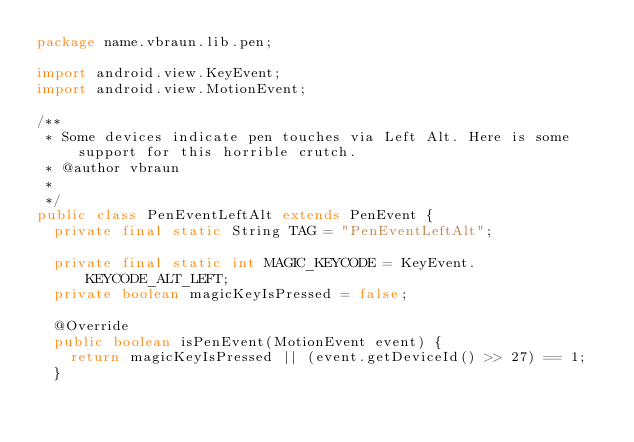<code> <loc_0><loc_0><loc_500><loc_500><_Java_>package name.vbraun.lib.pen;

import android.view.KeyEvent;
import android.view.MotionEvent;

/**
 * Some devices indicate pen touches via Left Alt. Here is some support for this horrible crutch.
 * @author vbraun
 *
 */
public class PenEventLeftAlt extends PenEvent {
	private final static String TAG = "PenEventLeftAlt";

	private final static int MAGIC_KEYCODE = KeyEvent.KEYCODE_ALT_LEFT;
	private boolean magicKeyIsPressed = false;
	
	@Override
	public boolean isPenEvent(MotionEvent event) {
		return magicKeyIsPressed || (event.getDeviceId() >> 27) == 1;
	}</code> 